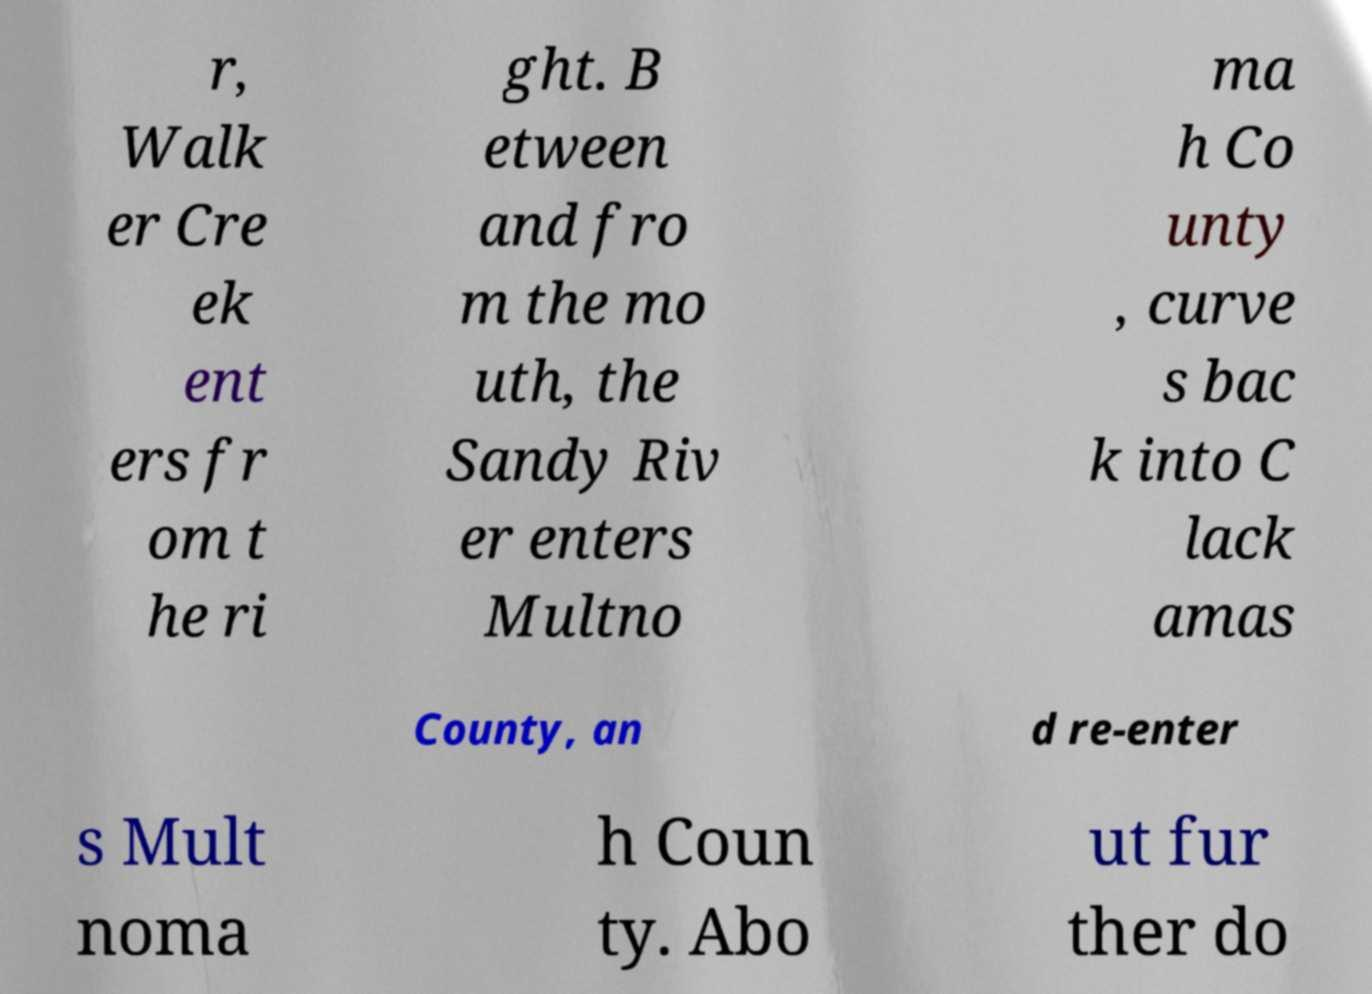What messages or text are displayed in this image? I need them in a readable, typed format. r, Walk er Cre ek ent ers fr om t he ri ght. B etween and fro m the mo uth, the Sandy Riv er enters Multno ma h Co unty , curve s bac k into C lack amas County, an d re-enter s Mult noma h Coun ty. Abo ut fur ther do 